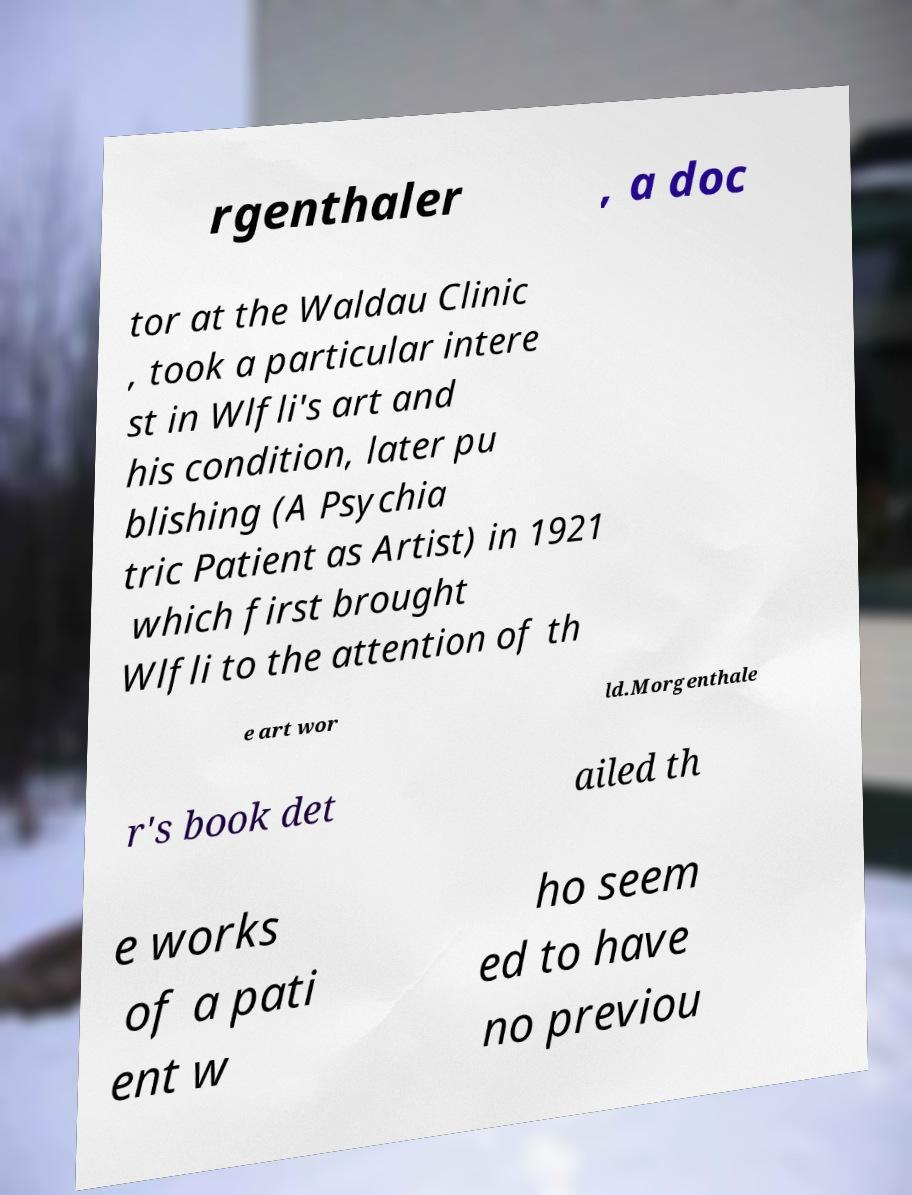I need the written content from this picture converted into text. Can you do that? rgenthaler , a doc tor at the Waldau Clinic , took a particular intere st in Wlfli's art and his condition, later pu blishing (A Psychia tric Patient as Artist) in 1921 which first brought Wlfli to the attention of th e art wor ld.Morgenthale r's book det ailed th e works of a pati ent w ho seem ed to have no previou 